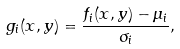Convert formula to latex. <formula><loc_0><loc_0><loc_500><loc_500>g _ { i } ( x , y ) = \frac { f _ { i } ( x , y ) - \mu _ { i } } { \sigma _ { i } } ,</formula> 